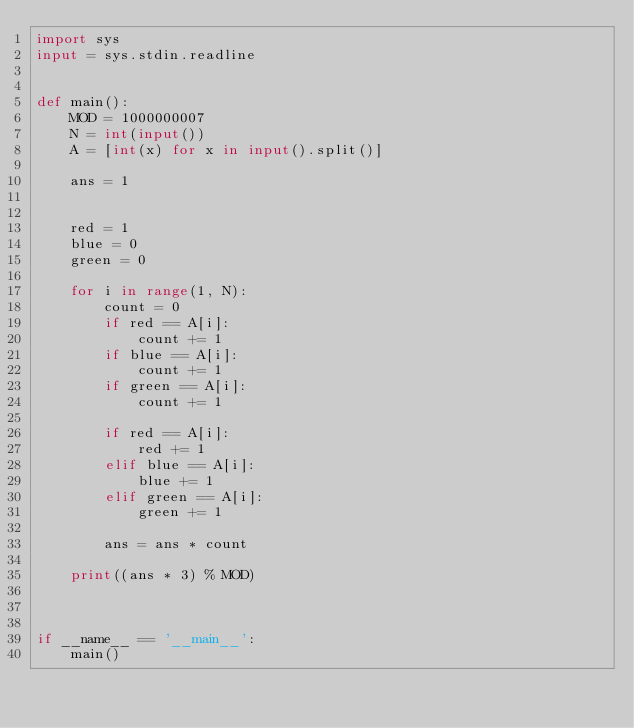Convert code to text. <code><loc_0><loc_0><loc_500><loc_500><_Python_>import sys
input = sys.stdin.readline


def main():
    MOD = 1000000007
    N = int(input())
    A = [int(x) for x in input().split()]

    ans = 1


    red = 1
    blue = 0
    green = 0

    for i in range(1, N):
        count = 0
        if red == A[i]:
            count += 1
        if blue == A[i]:
            count += 1
        if green == A[i]:
            count += 1

        if red == A[i]:
            red += 1
        elif blue == A[i]:
            blue += 1
        elif green == A[i]:
            green += 1

        ans = ans * count

    print((ans * 3) % MOD)



if __name__ == '__main__':
    main()

</code> 